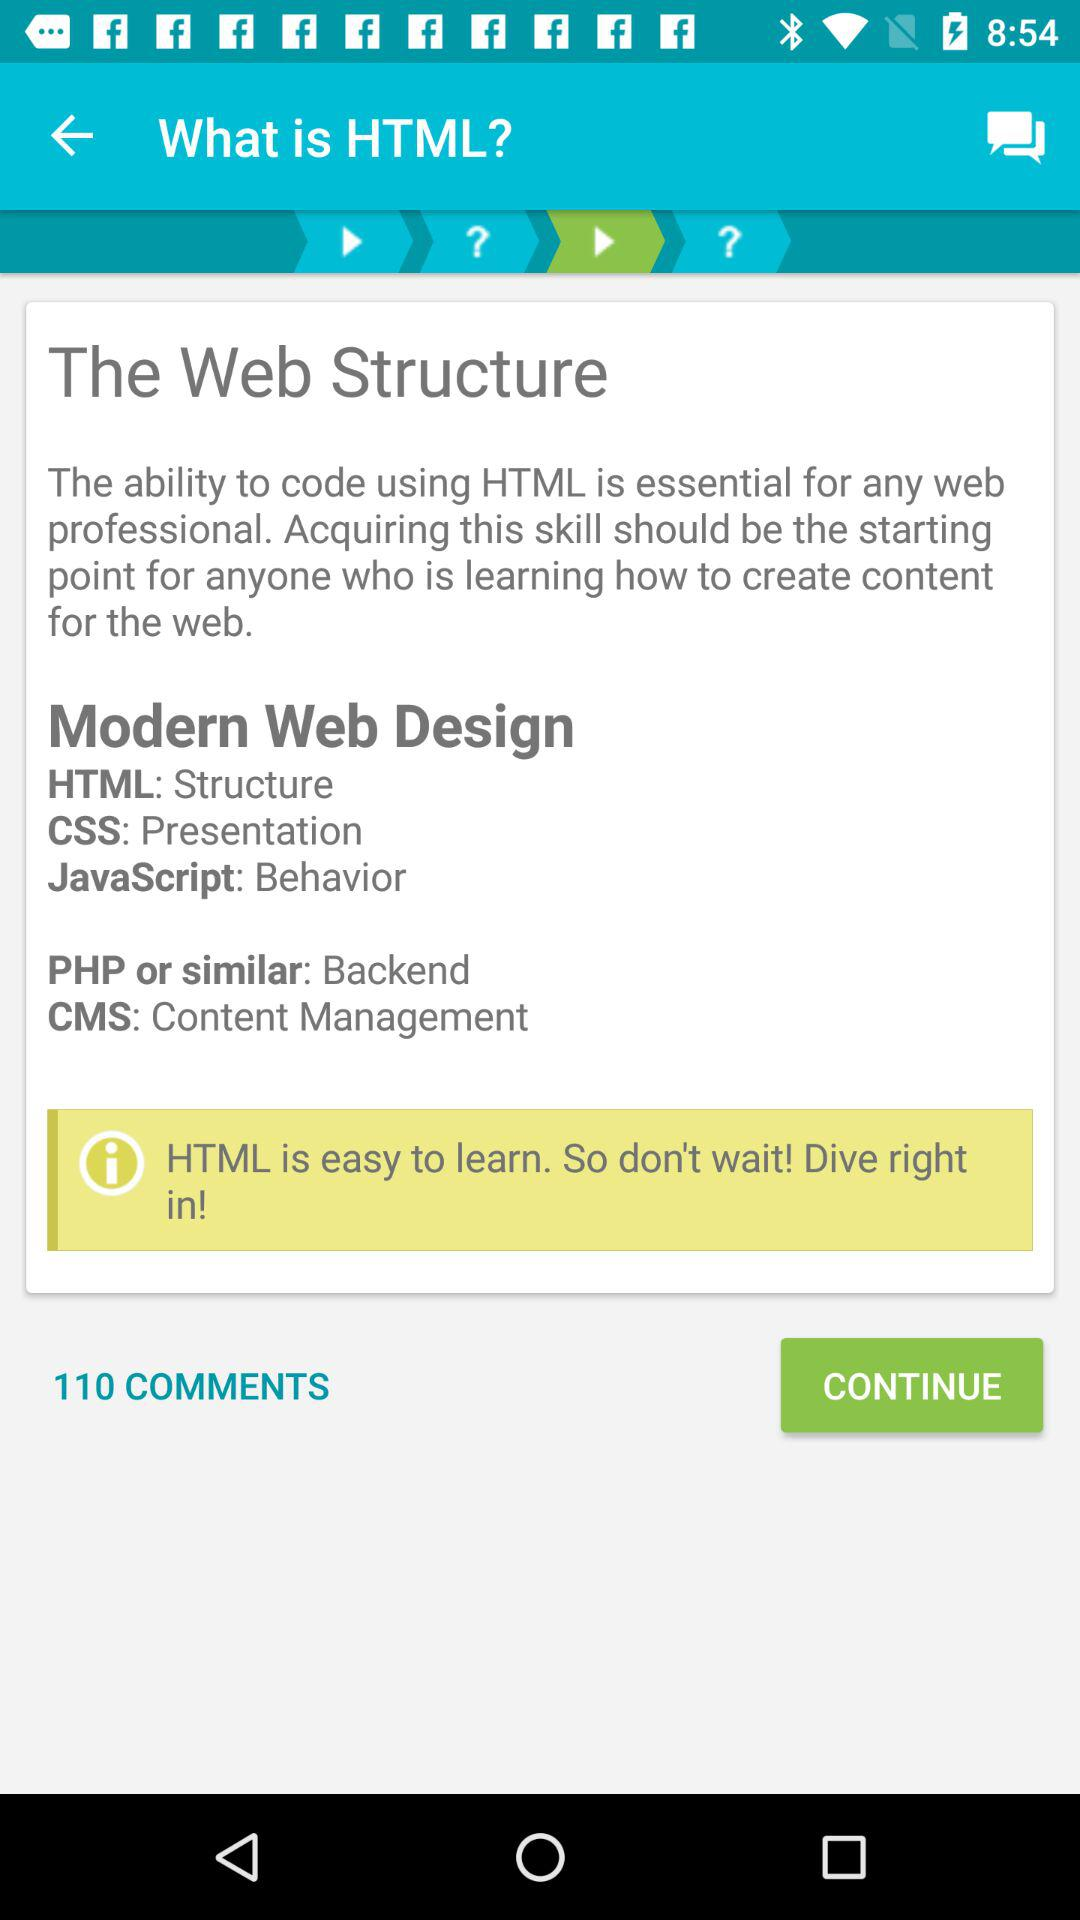What is the total number of comments? The total number of comments is 110. 